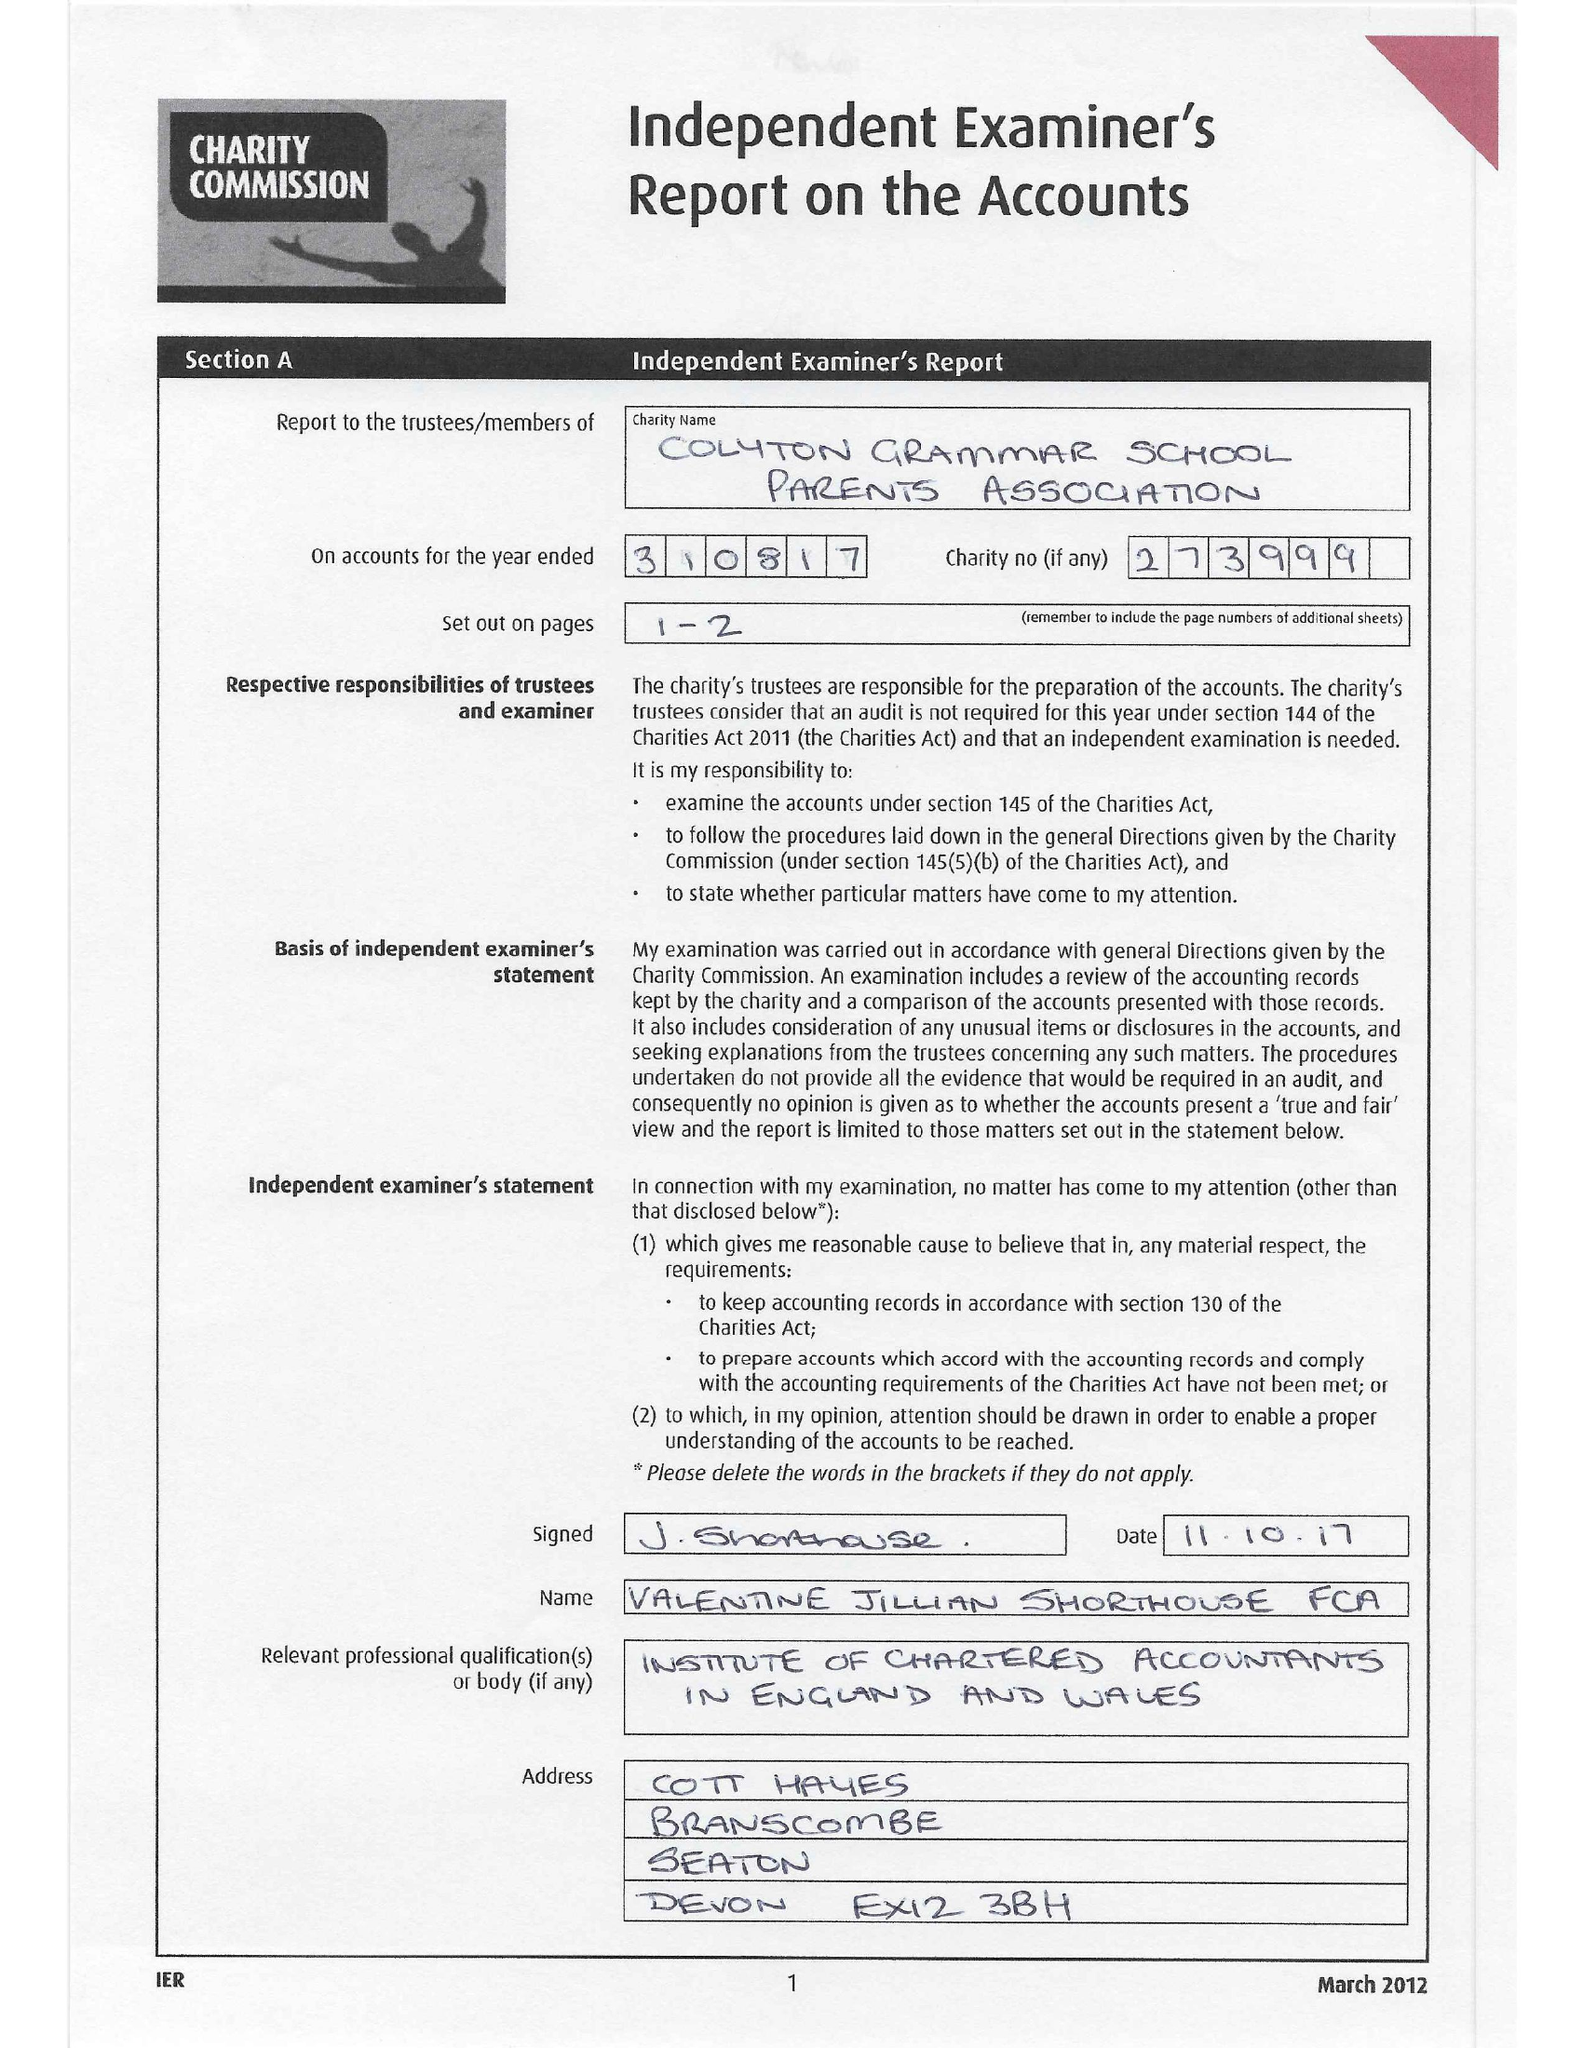What is the value for the address__street_line?
Answer the question using a single word or phrase. WHITWELL LANE 